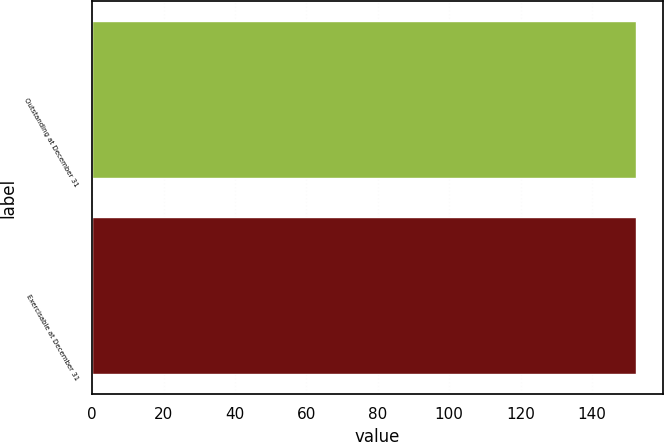Convert chart. <chart><loc_0><loc_0><loc_500><loc_500><bar_chart><fcel>Outstanding at December 31<fcel>Exercisable at December 31<nl><fcel>152.23<fcel>152.33<nl></chart> 